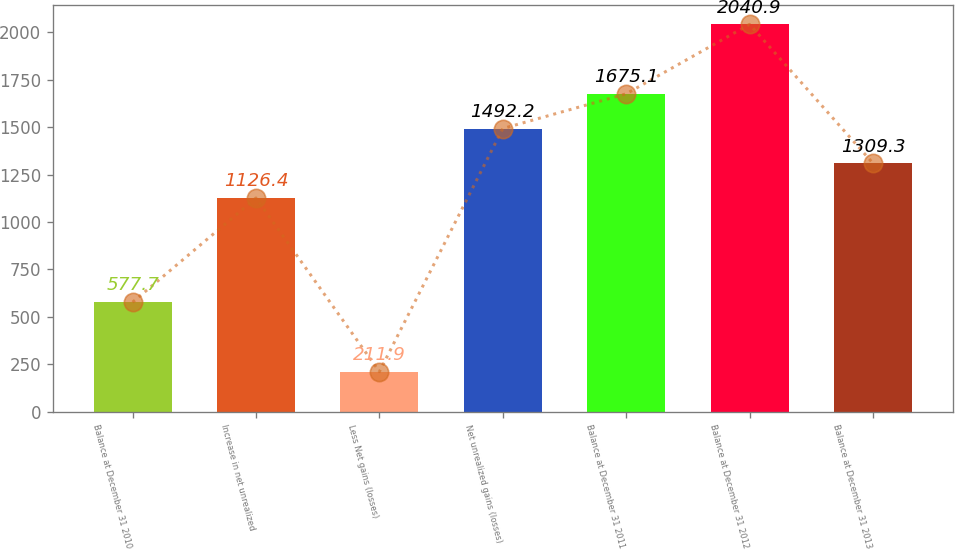Convert chart. <chart><loc_0><loc_0><loc_500><loc_500><bar_chart><fcel>Balance at December 31 2010<fcel>Increase in net unrealized<fcel>Less Net gains (losses)<fcel>Net unrealized gains (losses)<fcel>Balance at December 31 2011<fcel>Balance at December 31 2012<fcel>Balance at December 31 2013<nl><fcel>577.7<fcel>1126.4<fcel>211.9<fcel>1492.2<fcel>1675.1<fcel>2040.9<fcel>1309.3<nl></chart> 